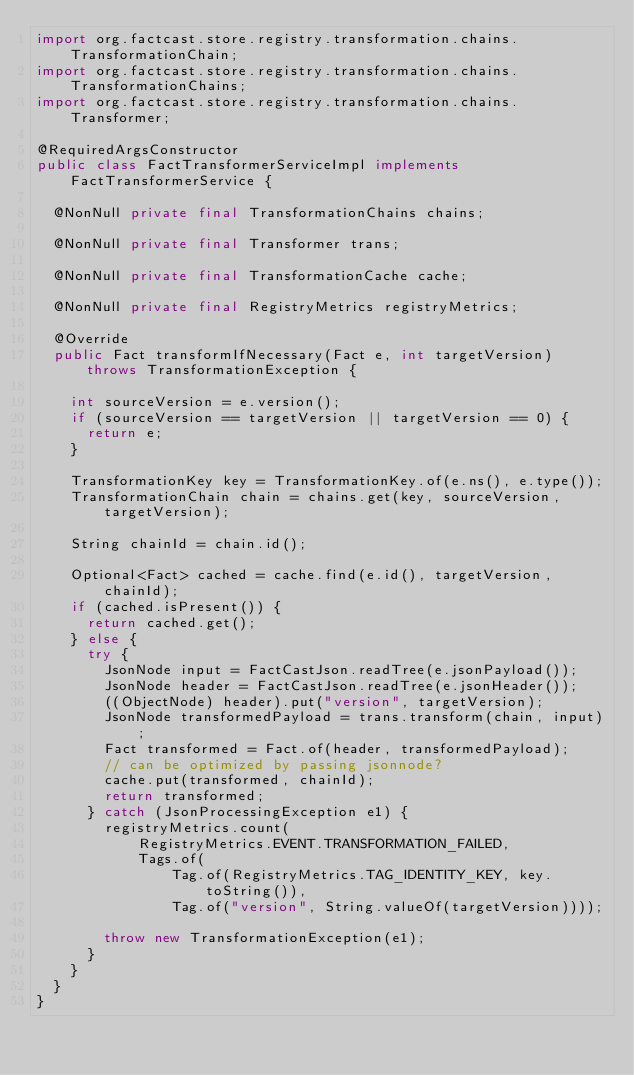<code> <loc_0><loc_0><loc_500><loc_500><_Java_>import org.factcast.store.registry.transformation.chains.TransformationChain;
import org.factcast.store.registry.transformation.chains.TransformationChains;
import org.factcast.store.registry.transformation.chains.Transformer;

@RequiredArgsConstructor
public class FactTransformerServiceImpl implements FactTransformerService {

  @NonNull private final TransformationChains chains;

  @NonNull private final Transformer trans;

  @NonNull private final TransformationCache cache;

  @NonNull private final RegistryMetrics registryMetrics;

  @Override
  public Fact transformIfNecessary(Fact e, int targetVersion) throws TransformationException {

    int sourceVersion = e.version();
    if (sourceVersion == targetVersion || targetVersion == 0) {
      return e;
    }

    TransformationKey key = TransformationKey.of(e.ns(), e.type());
    TransformationChain chain = chains.get(key, sourceVersion, targetVersion);

    String chainId = chain.id();

    Optional<Fact> cached = cache.find(e.id(), targetVersion, chainId);
    if (cached.isPresent()) {
      return cached.get();
    } else {
      try {
        JsonNode input = FactCastJson.readTree(e.jsonPayload());
        JsonNode header = FactCastJson.readTree(e.jsonHeader());
        ((ObjectNode) header).put("version", targetVersion);
        JsonNode transformedPayload = trans.transform(chain, input);
        Fact transformed = Fact.of(header, transformedPayload);
        // can be optimized by passing jsonnode?
        cache.put(transformed, chainId);
        return transformed;
      } catch (JsonProcessingException e1) {
        registryMetrics.count(
            RegistryMetrics.EVENT.TRANSFORMATION_FAILED,
            Tags.of(
                Tag.of(RegistryMetrics.TAG_IDENTITY_KEY, key.toString()),
                Tag.of("version", String.valueOf(targetVersion))));

        throw new TransformationException(e1);
      }
    }
  }
}
</code> 